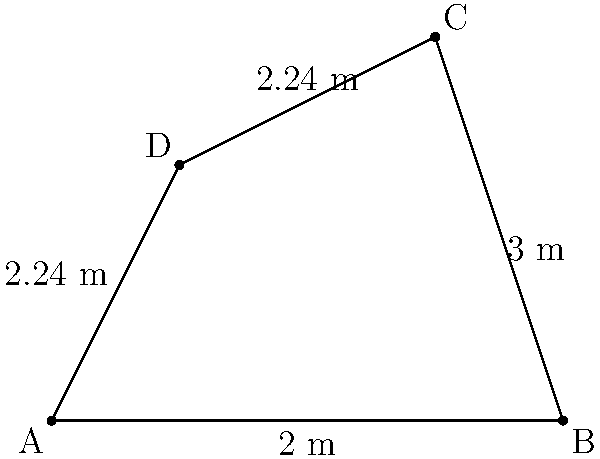In an AR environment, you've tracked four points (A, B, C, and D) to form a quadrilateral. Given the distances between the points as shown in the diagram, calculate the area of the polygon in square meters. Round your answer to two decimal places. To find the area of this irregular quadrilateral, we can divide it into two triangles and sum their areas. Let's split it into triangles ABC and ACD.

1. For triangle ABC:
   - We know the base (AB) = 4 m and height (perpendicular from C to AB) = 3 m
   - Area of ABC = $\frac{1}{2} \times base \times height = \frac{1}{2} \times 4 \times 3 = 6$ sq m

2. For triangle ACD:
   - We need to use Heron's formula as we only know the side lengths
   - Let s be the semi-perimeter of ACD
   - $s = \frac{AD + DC + AC}{2} = \frac{2.24 + 2.24 + \sqrt{1^2 + 2^2}}{2} = \frac{4.48 + \sqrt{5}}{2}$
   - Area of ACD = $\sqrt{s(s-AD)(s-DC)(s-AC)}$
   - $= \sqrt{(\frac{4.48 + \sqrt{5}}{2})(\frac{4.48 + \sqrt{5}}{2}-2.24)(\frac{4.48 + \sqrt{5}}{2}-2.24)(\frac{4.48 + \sqrt{5}}{2}-\sqrt{5})}$
   - $\approx 2.24$ sq m

3. Total area = Area of ABC + Area of ACD
   $= 6 + 2.24 = 8.24$ sq m

Rounding to two decimal places, we get 8.24 sq m.
Answer: 8.24 sq m 